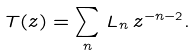Convert formula to latex. <formula><loc_0><loc_0><loc_500><loc_500>T ( z ) = \sum _ { n } \, L _ { n } \, z ^ { - n - 2 } .</formula> 